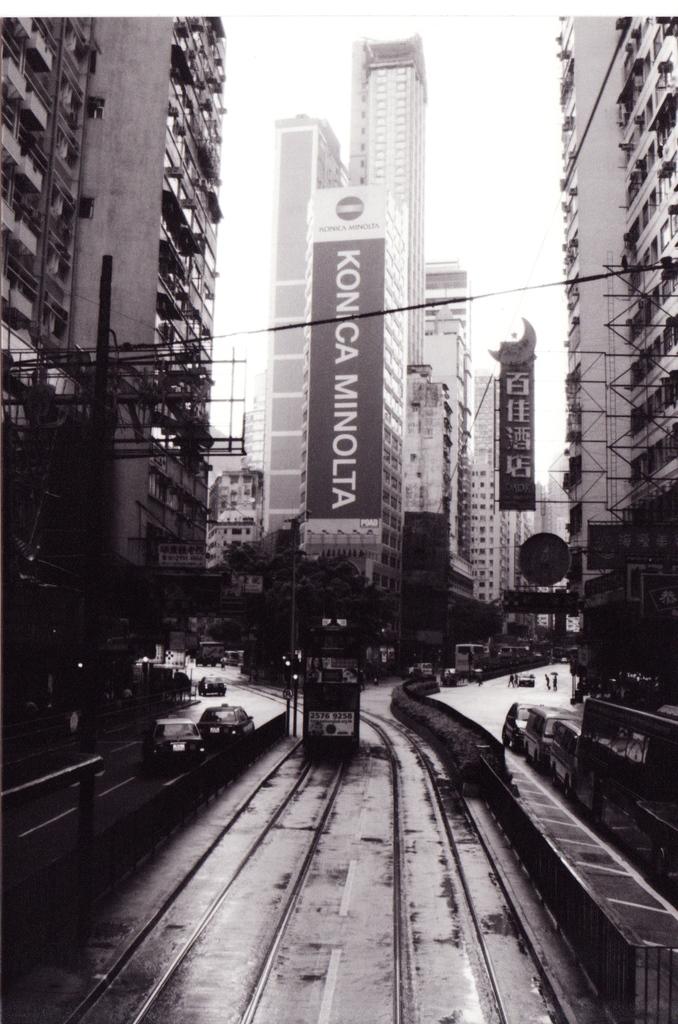What is being advertised on the side of the building?
Your answer should be compact. Konica minolta. 